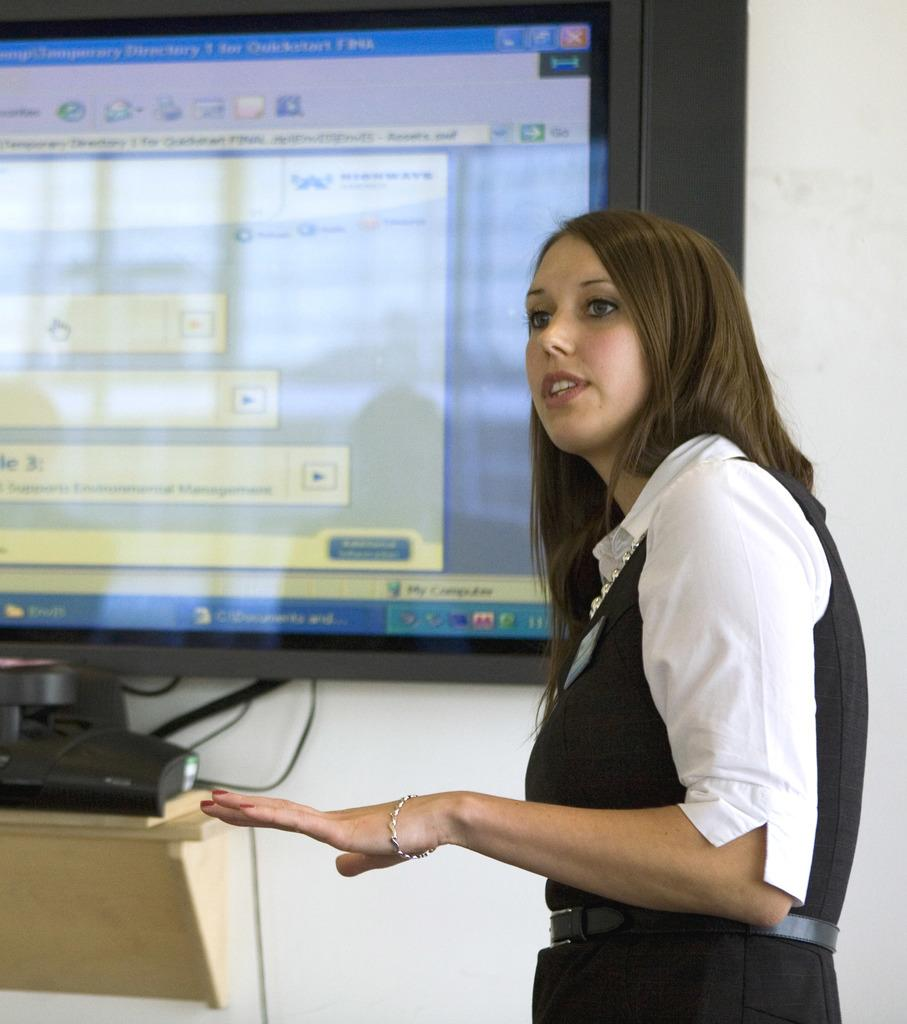Who is present in the image? There is a woman in the image. Where is the woman located in the image? The woman is on the right side of the image. What can be seen in the background of the image? There is a large screen and a wall in the background of the image. What type of bomb is being discussed by the organization in the image? There is no bomb or organization present in the image. The image only features a woman on the right side, a large screen, and a wall in the background. 